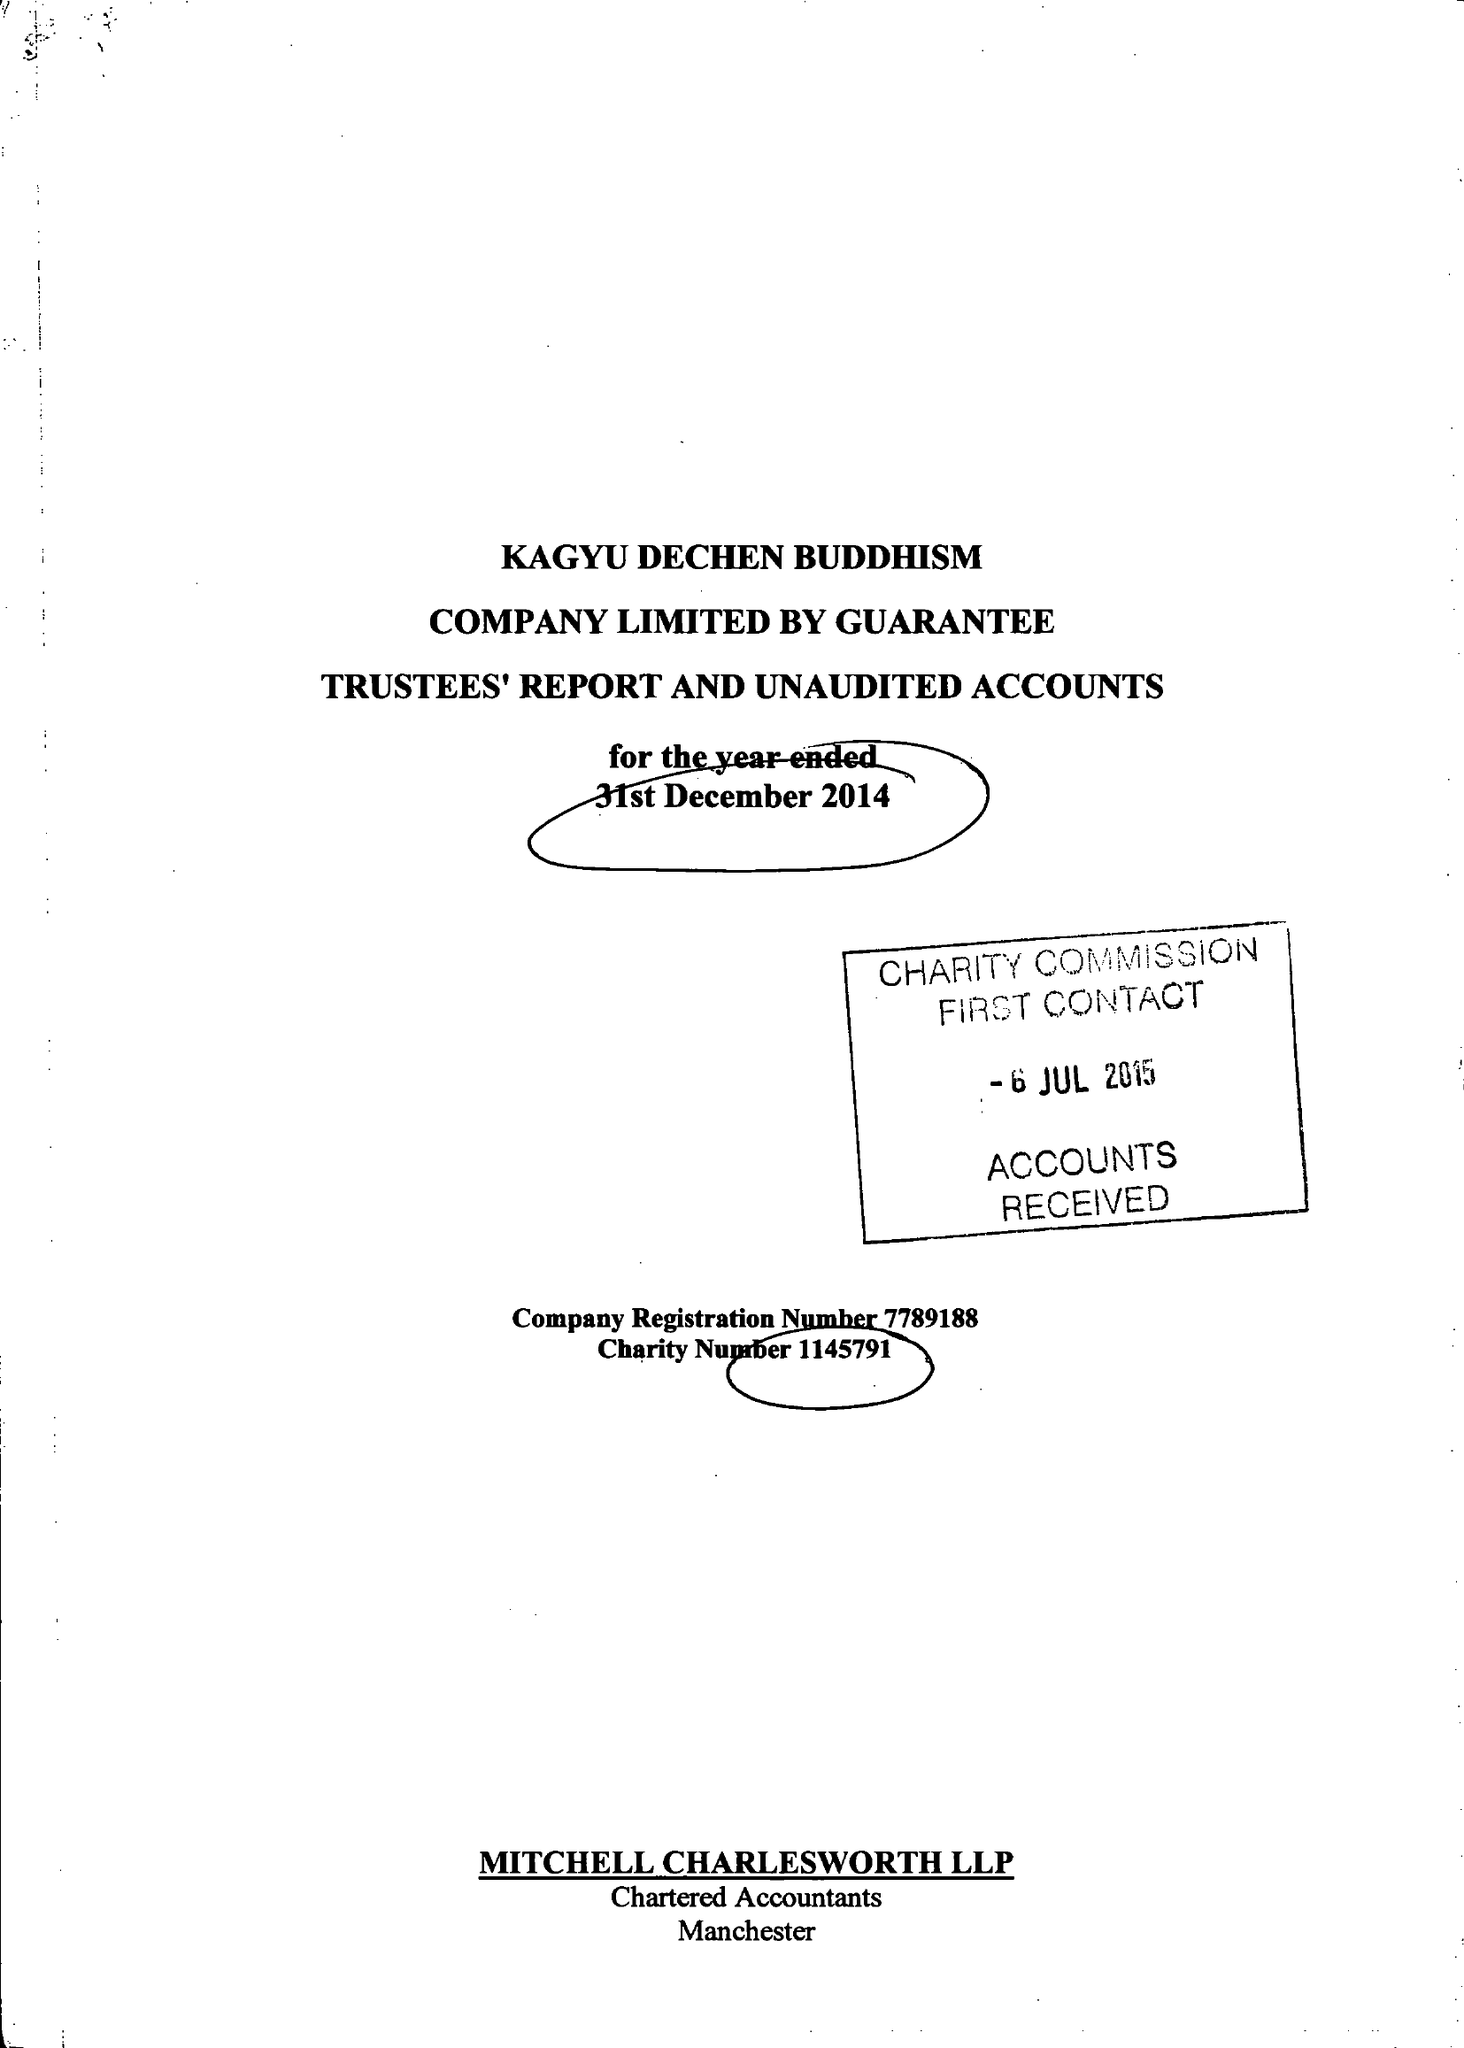What is the value for the charity_name?
Answer the question using a single word or phrase. Kagyu Dechen Buddhism 